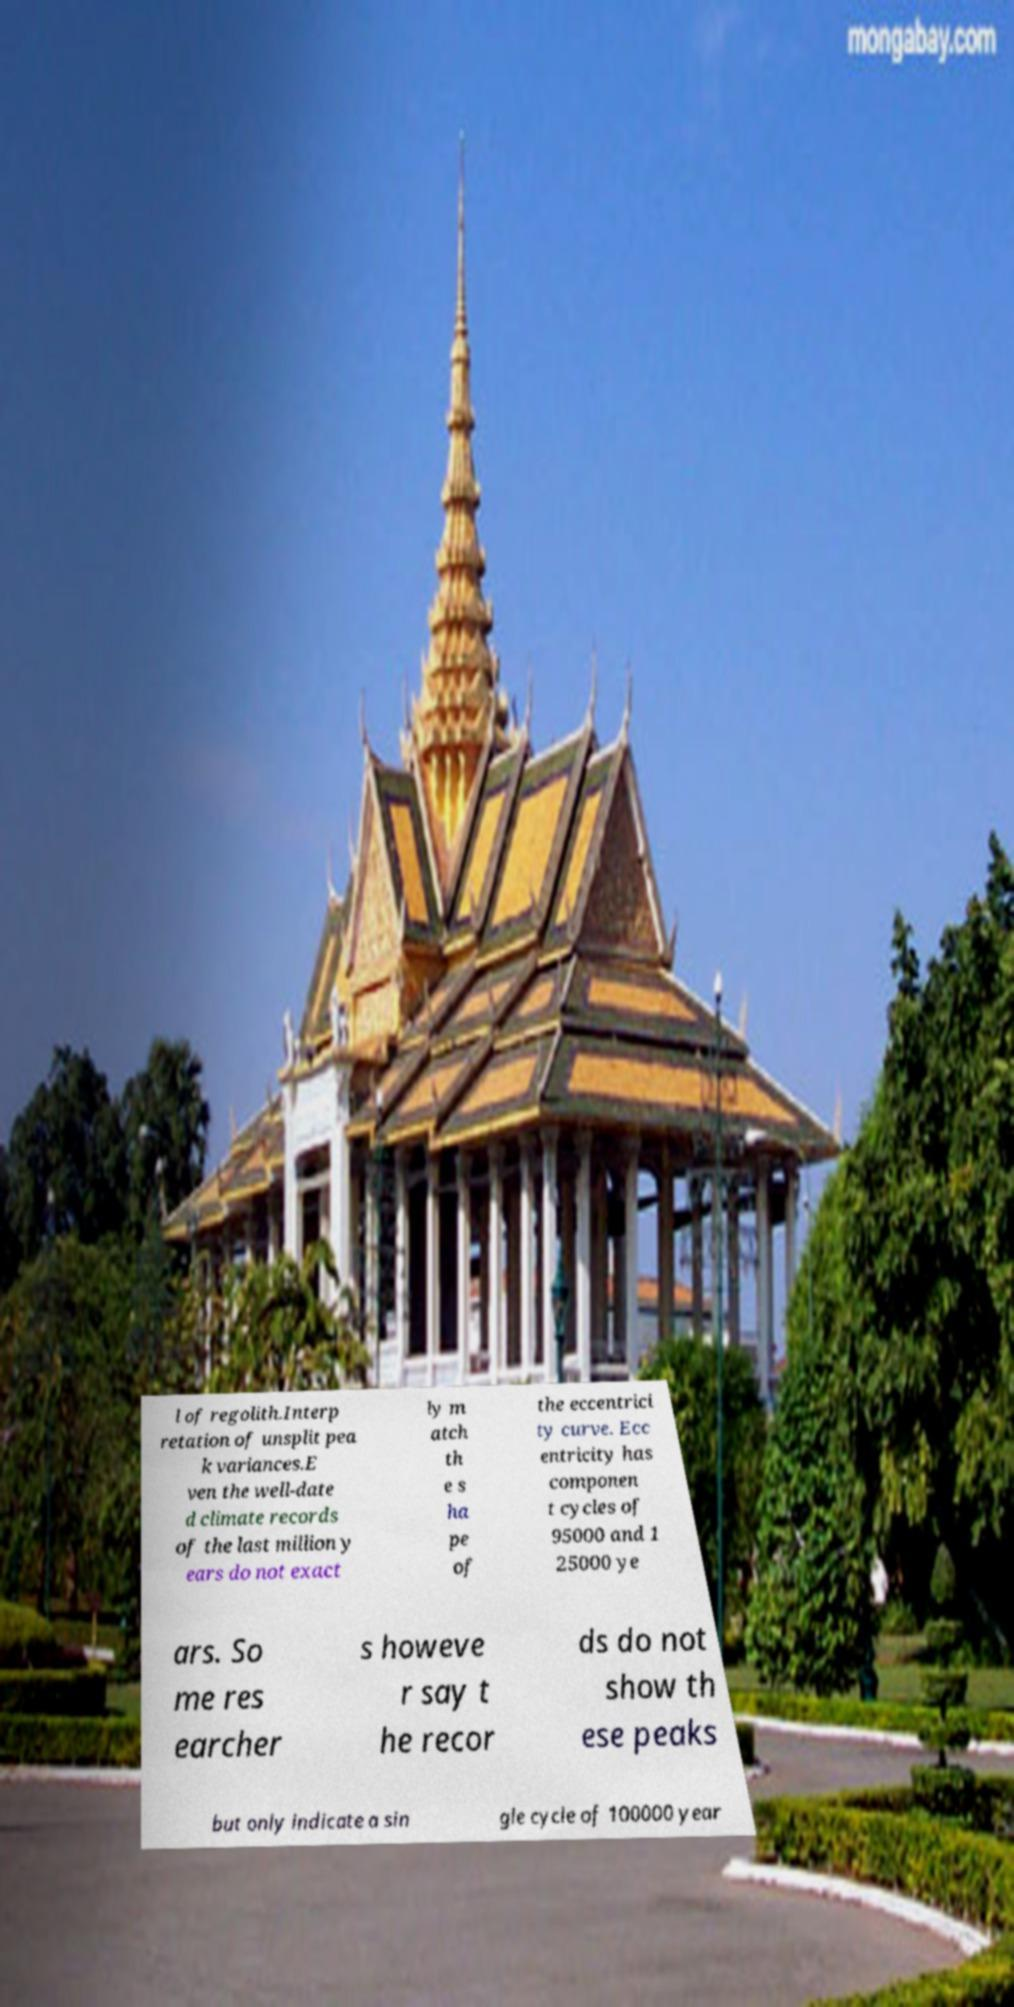Please read and relay the text visible in this image. What does it say? l of regolith.Interp retation of unsplit pea k variances.E ven the well-date d climate records of the last million y ears do not exact ly m atch th e s ha pe of the eccentrici ty curve. Ecc entricity has componen t cycles of 95000 and 1 25000 ye ars. So me res earcher s howeve r say t he recor ds do not show th ese peaks but only indicate a sin gle cycle of 100000 year 